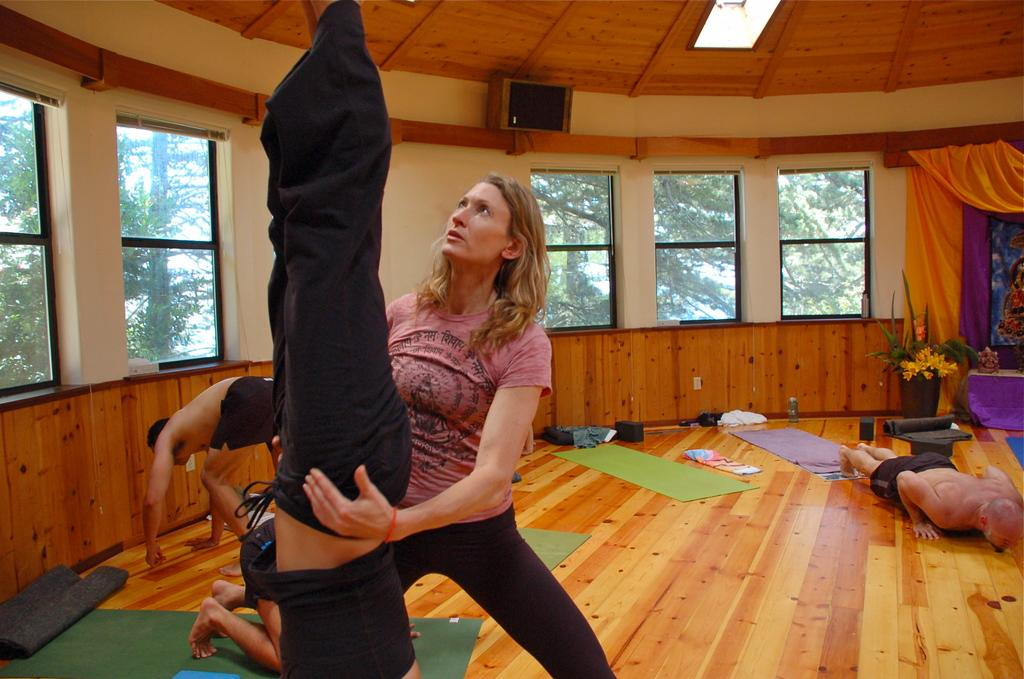What are the people in the image doing? The people in the image are doing yoga. Is there anyone else in the image besides the people doing yoga? Yes, there is a woman standing and watching in the image. What can be seen through the windows in the image? The windows in the image allow us to see the surroundings, but the specific view is not mentioned in the facts. What type of structure is visible in the image? There is a wall in the image, which suggests that the scene is taking place indoors. What word is being spoken by the people doing yoga in the image? There is no information about any spoken words in the image, so we cannot determine what word might be spoken by the people doing yoga. 